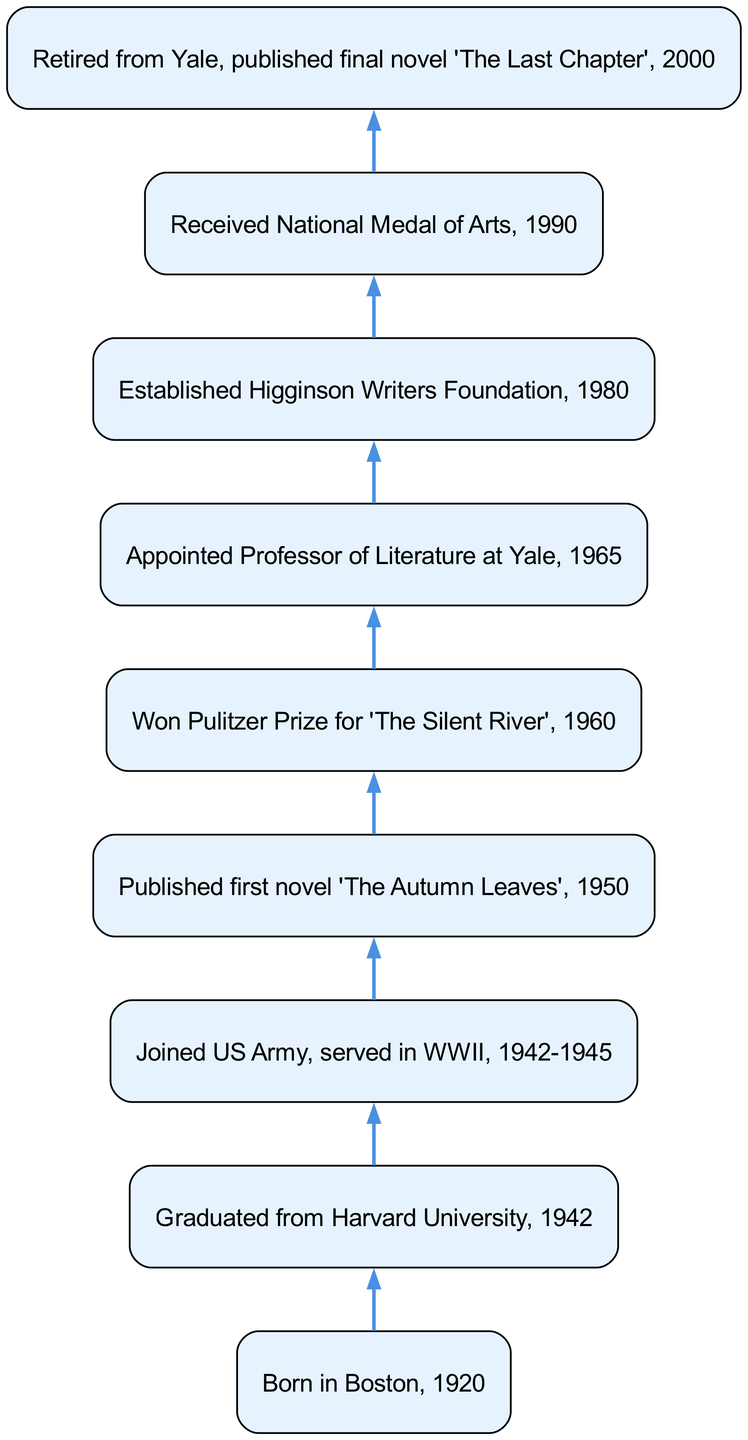What year was S.J. Higginson born? The diagram indicates that S.J. Higginson was born in Boston. The information is located at the first node in the flowchart, which states "Born in Boston, 1920."
Answer: 1920 How many nodes are there in the diagram? By counting the individual milestones and events represented as nodes in the diagram, we find that there are a total of 9 nodes.
Answer: 9 What is the first novel published by S.J. Higginson? The fourth node in the chart mentions the publication of the first novel, stating "Published first novel 'The Autumn Leaves', 1950."
Answer: The Autumn Leaves What award did S.J. Higginson win in 1960? Referring to the fifth node, it specifies the achievement, which is "Won Pulitzer Prize for 'The Silent River', 1960."
Answer: Pulitzer Prize What significant event occurred in 1980? Following the flow from the sixth node to the seventh node, we observe the establishment of an organization indicating "Established Higginson Writers Foundation, 1980."
Answer: Established Higginson Writers Foundation What did S.J. Higginson do after retiring from Yale? The final node discusses activities after retirement and states "Retired from Yale, published final novel 'The Last Chapter', 2000." Therefore, the significant activity mentioned after retirement is publishing the last novel.
Answer: Published final novel 'The Last Chapter' How many awards did S.J. Higginson receive according to the diagram? By reviewing the milestones, S.J. Higginson received at least two distinct awards: the Pulitzer Prize in 1960 and the National Medal of Arts in 1990.
Answer: 2 Which milestone directly followed S.J. Higginson’s military service? Continuing from node three which details service in WWII, the subsequent node four indicates a milestone "Published first novel 'The Autumn Leaves', 1950," showing that publishing the novel directly followed his military service.
Answer: Published first novel 'The Autumn Leaves' What is the flow direction of the diagram? The diagram is structured as a bottom-up flow chart, indicating that it starts from the birth of S.J. Higginson and progresses upwards through various milestones in his career, moving from early life to retirement.
Answer: Bottom-up 